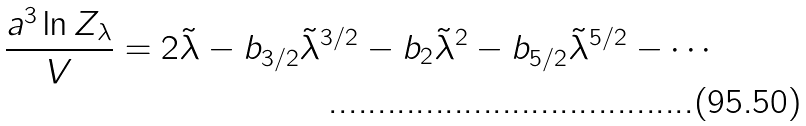Convert formula to latex. <formula><loc_0><loc_0><loc_500><loc_500>\frac { a ^ { 3 } \ln Z _ { \lambda } } { V } = 2 \tilde { \lambda } - b _ { 3 / 2 } \tilde { \lambda } ^ { 3 / 2 } - b _ { 2 } \tilde { \lambda } ^ { 2 } - b _ { 5 / 2 } \tilde { \lambda } ^ { 5 / 2 } - \cdots</formula> 